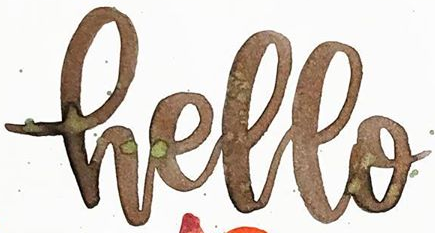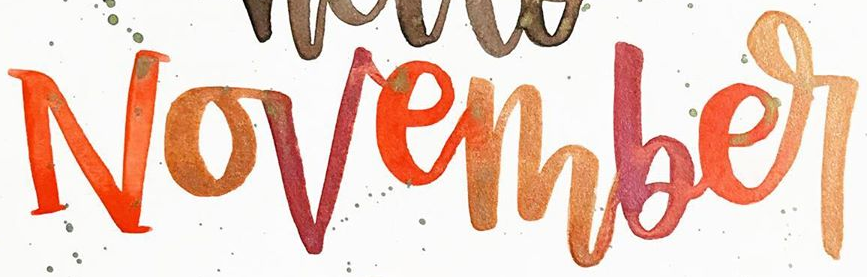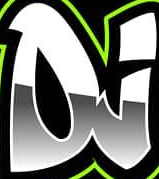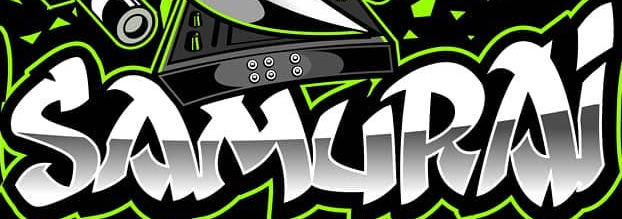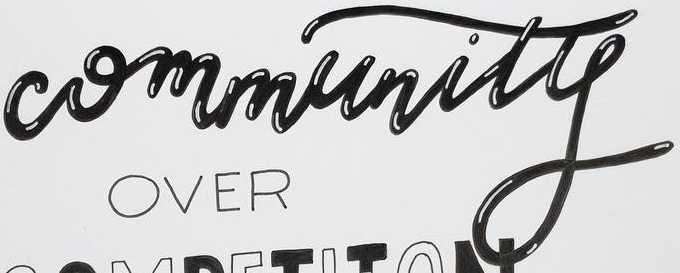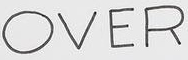Transcribe the words shown in these images in order, separated by a semicolon. Hello; November; DJ; SAMURAi; Community; OVER 